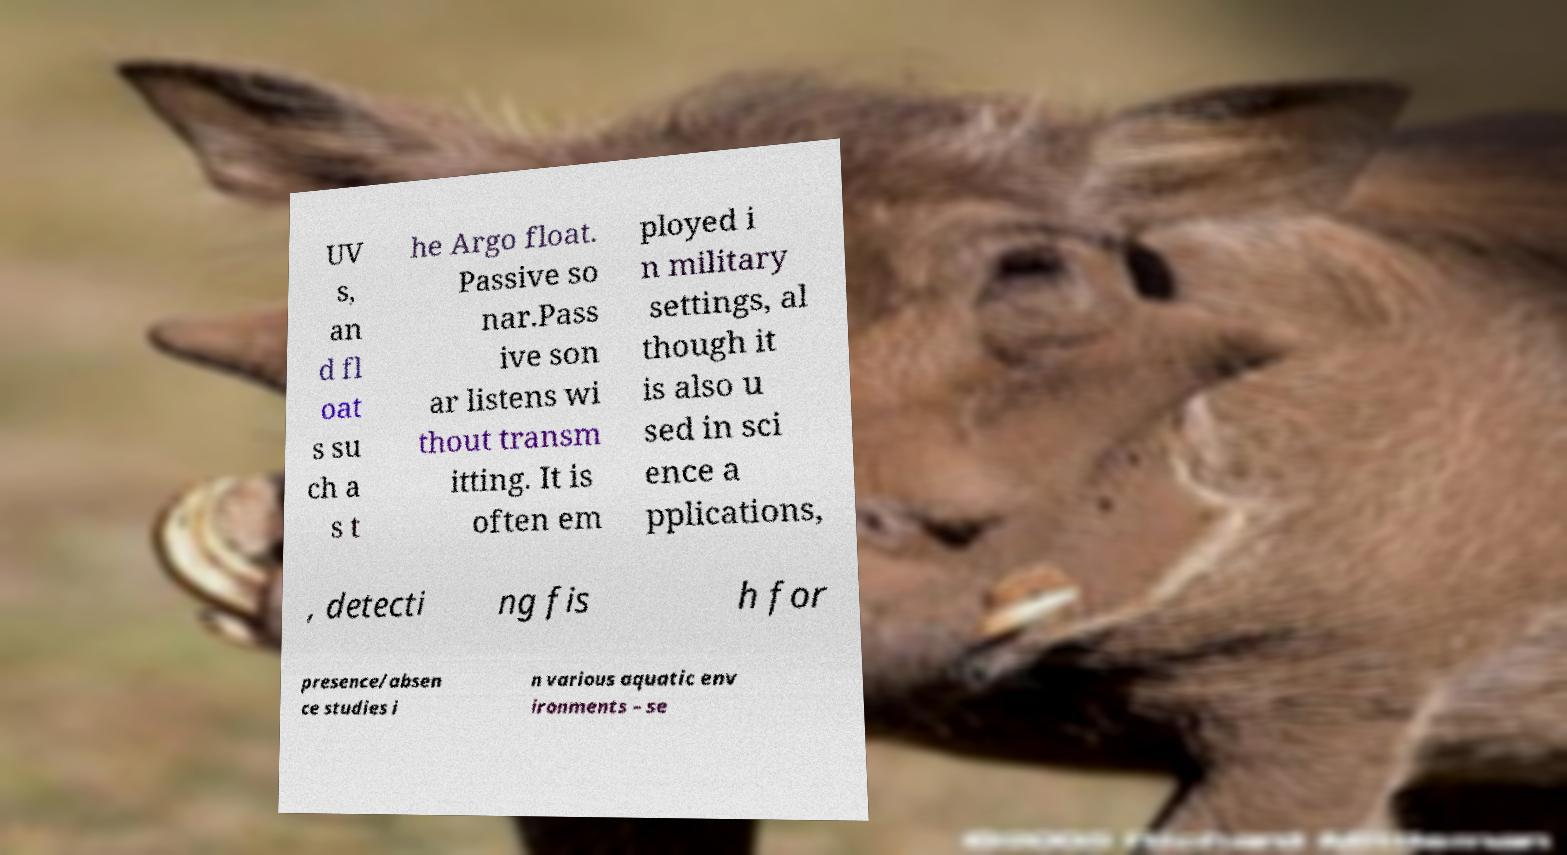Please identify and transcribe the text found in this image. UV s, an d fl oat s su ch a s t he Argo float. Passive so nar.Pass ive son ar listens wi thout transm itting. It is often em ployed i n military settings, al though it is also u sed in sci ence a pplications, , detecti ng fis h for presence/absen ce studies i n various aquatic env ironments – se 